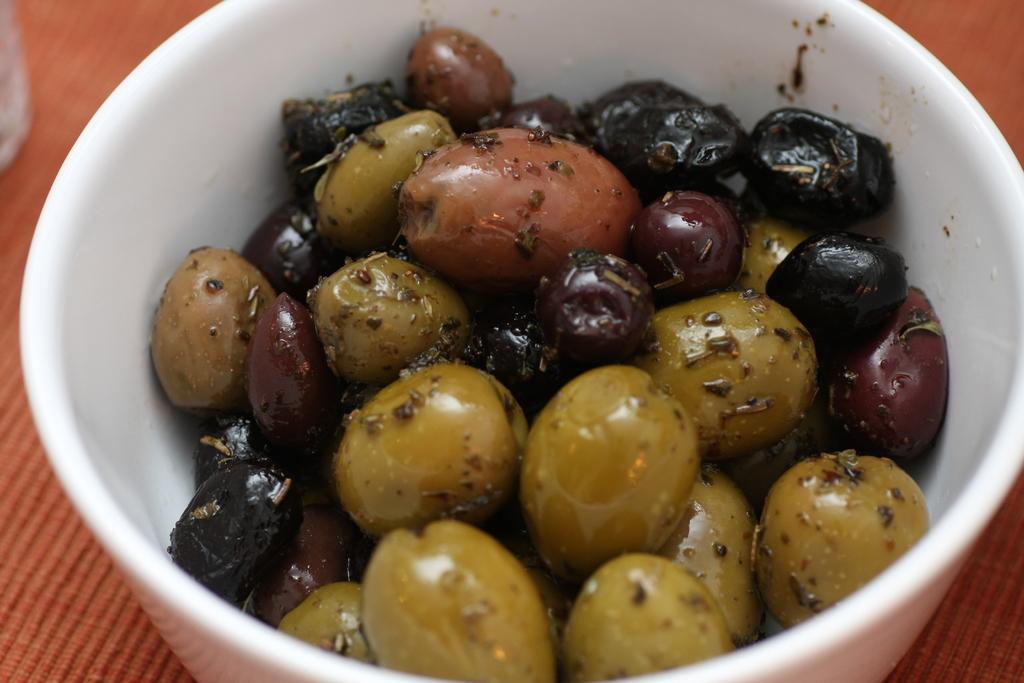In one or two sentences, can you explain what this image depicts? In this image I can see a food in the white color bowl. Food is in black, maroon and green color. It is on the brown surface. 